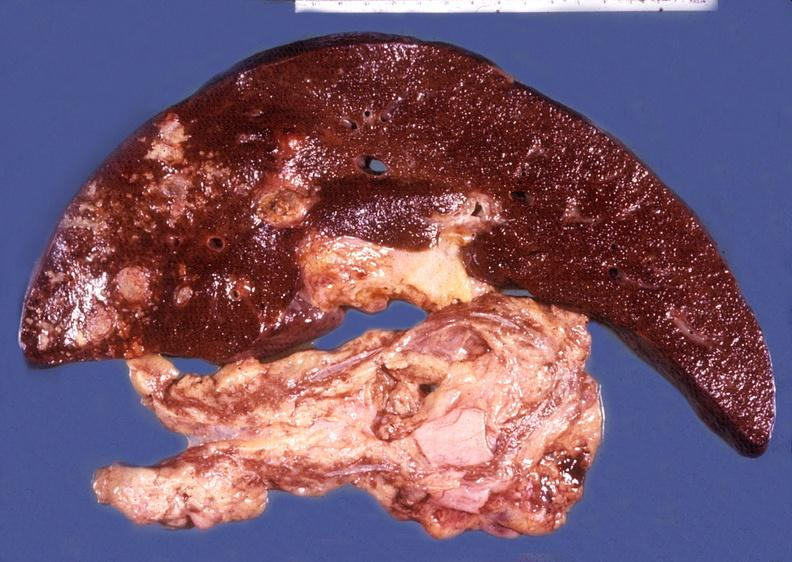does this image show liver and pancreas, hemochromatosis and liver hepatoma?
Answer the question using a single word or phrase. Yes 